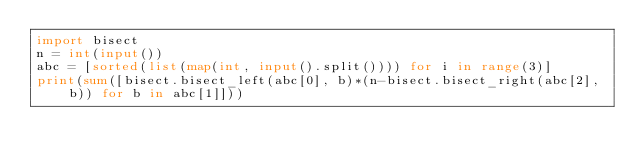Convert code to text. <code><loc_0><loc_0><loc_500><loc_500><_Python_>import bisect
n = int(input())
abc = [sorted(list(map(int, input().split()))) for i in range(3)]
print(sum([bisect.bisect_left(abc[0], b)*(n-bisect.bisect_right(abc[2], b)) for b in abc[1]]))</code> 